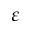<formula> <loc_0><loc_0><loc_500><loc_500>\varepsilon</formula> 